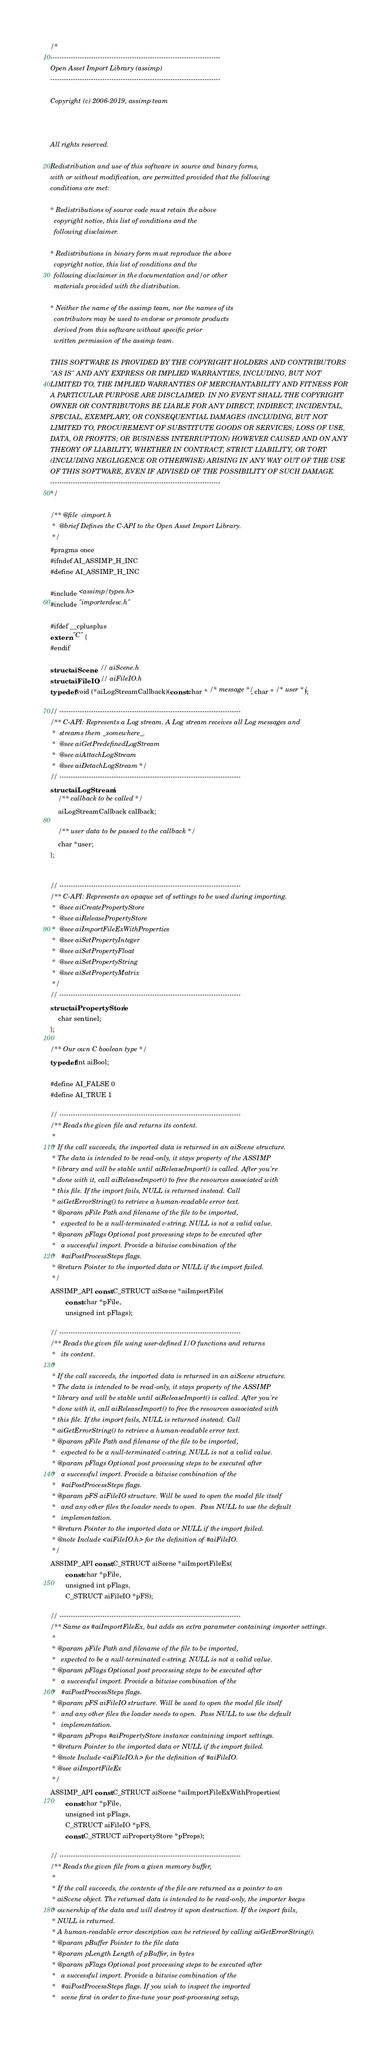Convert code to text. <code><loc_0><loc_0><loc_500><loc_500><_C_>/*
---------------------------------------------------------------------------
Open Asset Import Library (assimp)
---------------------------------------------------------------------------

Copyright (c) 2006-2019, assimp team



All rights reserved.

Redistribution and use of this software in source and binary forms,
with or without modification, are permitted provided that the following
conditions are met:

* Redistributions of source code must retain the above
  copyright notice, this list of conditions and the
  following disclaimer.

* Redistributions in binary form must reproduce the above
  copyright notice, this list of conditions and the
  following disclaimer in the documentation and/or other
  materials provided with the distribution.

* Neither the name of the assimp team, nor the names of its
  contributors may be used to endorse or promote products
  derived from this software without specific prior
  written permission of the assimp team.

THIS SOFTWARE IS PROVIDED BY THE COPYRIGHT HOLDERS AND CONTRIBUTORS
"AS IS" AND ANY EXPRESS OR IMPLIED WARRANTIES, INCLUDING, BUT NOT
LIMITED TO, THE IMPLIED WARRANTIES OF MERCHANTABILITY AND FITNESS FOR
A PARTICULAR PURPOSE ARE DISCLAIMED. IN NO EVENT SHALL THE COPYRIGHT
OWNER OR CONTRIBUTORS BE LIABLE FOR ANY DIRECT, INDIRECT, INCIDENTAL,
SPECIAL, EXEMPLARY, OR CONSEQUENTIAL DAMAGES (INCLUDING, BUT NOT
LIMITED TO, PROCUREMENT OF SUBSTITUTE GOODS OR SERVICES; LOSS OF USE,
DATA, OR PROFITS; OR BUSINESS INTERRUPTION) HOWEVER CAUSED AND ON ANY
THEORY OF LIABILITY, WHETHER IN CONTRACT, STRICT LIABILITY, OR TORT
(INCLUDING NEGLIGENCE OR OTHERWISE) ARISING IN ANY WAY OUT OF THE USE
OF THIS SOFTWARE, EVEN IF ADVISED OF THE POSSIBILITY OF SUCH DAMAGE.
---------------------------------------------------------------------------
*/

/** @file  cimport.h
 *  @brief Defines the C-API to the Open Asset Import Library.
 */
#pragma once
#ifndef AI_ASSIMP_H_INC
#define AI_ASSIMP_H_INC

#include <assimp/types.h>
#include "importerdesc.h"

#ifdef __cplusplus
extern "C" {
#endif

struct aiScene;  // aiScene.h
struct aiFileIO; // aiFileIO.h
typedef void (*aiLogStreamCallback)(const char * /* message */, char * /* user */);

// --------------------------------------------------------------------------------
/** C-API: Represents a Log stream. A Log stream receives all Log messages and
 *  streams them _somewhere_.
 *  @see aiGetPredefinedLogStream
 *  @see aiAttachLogStream
 *  @see aiDetachLogStream */
// --------------------------------------------------------------------------------
struct aiLogStream {
    /** callback to be called */
    aiLogStreamCallback callback;

    /** user data to be passed to the callback */
    char *user;
};


// --------------------------------------------------------------------------------
/** C-API: Represents an opaque set of settings to be used during importing.
 *  @see aiCreatePropertyStore
 *  @see aiReleasePropertyStore
 *  @see aiImportFileExWithProperties
 *  @see aiSetPropertyInteger
 *  @see aiSetPropertyFloat
 *  @see aiSetPropertyString
 *  @see aiSetPropertyMatrix
 */
// --------------------------------------------------------------------------------
struct aiPropertyStore {
    char sentinel;
};

/** Our own C boolean type */
typedef int aiBool;

#define AI_FALSE 0
#define AI_TRUE 1

// --------------------------------------------------------------------------------
/** Reads the given file and returns its content.
 *
 * If the call succeeds, the imported data is returned in an aiScene structure.
 * The data is intended to be read-only, it stays property of the ASSIMP
 * library and will be stable until aiReleaseImport() is called. After you're
 * done with it, call aiReleaseImport() to free the resources associated with
 * this file. If the import fails, NULL is returned instead. Call
 * aiGetErrorString() to retrieve a human-readable error text.
 * @param pFile Path and filename of the file to be imported,
 *   expected to be a null-terminated c-string. NULL is not a valid value.
 * @param pFlags Optional post processing steps to be executed after
 *   a successful import. Provide a bitwise combination of the
 *   #aiPostProcessSteps flags.
 * @return Pointer to the imported data or NULL if the import failed.
 */
ASSIMP_API const C_STRUCT aiScene *aiImportFile(
        const char *pFile,
        unsigned int pFlags);

// --------------------------------------------------------------------------------
/** Reads the given file using user-defined I/O functions and returns
 *   its content.
 *
 * If the call succeeds, the imported data is returned in an aiScene structure.
 * The data is intended to be read-only, it stays property of the ASSIMP
 * library and will be stable until aiReleaseImport() is called. After you're
 * done with it, call aiReleaseImport() to free the resources associated with
 * this file. If the import fails, NULL is returned instead. Call
 * aiGetErrorString() to retrieve a human-readable error text.
 * @param pFile Path and filename of the file to be imported,
 *   expected to be a null-terminated c-string. NULL is not a valid value.
 * @param pFlags Optional post processing steps to be executed after
 *   a successful import. Provide a bitwise combination of the
 *   #aiPostProcessSteps flags.
 * @param pFS aiFileIO structure. Will be used to open the model file itself
 *   and any other files the loader needs to open.  Pass NULL to use the default
 *   implementation.
 * @return Pointer to the imported data or NULL if the import failed.
 * @note Include <aiFileIO.h> for the definition of #aiFileIO.
 */
ASSIMP_API const C_STRUCT aiScene *aiImportFileEx(
        const char *pFile,
        unsigned int pFlags,
        C_STRUCT aiFileIO *pFS);

// --------------------------------------------------------------------------------
/** Same as #aiImportFileEx, but adds an extra parameter containing importer settings.
 *
 * @param pFile Path and filename of the file to be imported,
 *   expected to be a null-terminated c-string. NULL is not a valid value.
 * @param pFlags Optional post processing steps to be executed after
 *   a successful import. Provide a bitwise combination of the
 *   #aiPostProcessSteps flags.
 * @param pFS aiFileIO structure. Will be used to open the model file itself
 *   and any other files the loader needs to open.  Pass NULL to use the default
 *   implementation.
 * @param pProps #aiPropertyStore instance containing import settings.
 * @return Pointer to the imported data or NULL if the import failed.
 * @note Include <aiFileIO.h> for the definition of #aiFileIO.
 * @see aiImportFileEx
 */
ASSIMP_API const C_STRUCT aiScene *aiImportFileExWithProperties(
        const char *pFile,
        unsigned int pFlags,
        C_STRUCT aiFileIO *pFS,
        const C_STRUCT aiPropertyStore *pProps);

// --------------------------------------------------------------------------------
/** Reads the given file from a given memory buffer,
 *
 * If the call succeeds, the contents of the file are returned as a pointer to an
 * aiScene object. The returned data is intended to be read-only, the importer keeps
 * ownership of the data and will destroy it upon destruction. If the import fails,
 * NULL is returned.
 * A human-readable error description can be retrieved by calling aiGetErrorString().
 * @param pBuffer Pointer to the file data
 * @param pLength Length of pBuffer, in bytes
 * @param pFlags Optional post processing steps to be executed after
 *   a successful import. Provide a bitwise combination of the
 *   #aiPostProcessSteps flags. If you wish to inspect the imported
 *   scene first in order to fine-tune your post-processing setup,</code> 